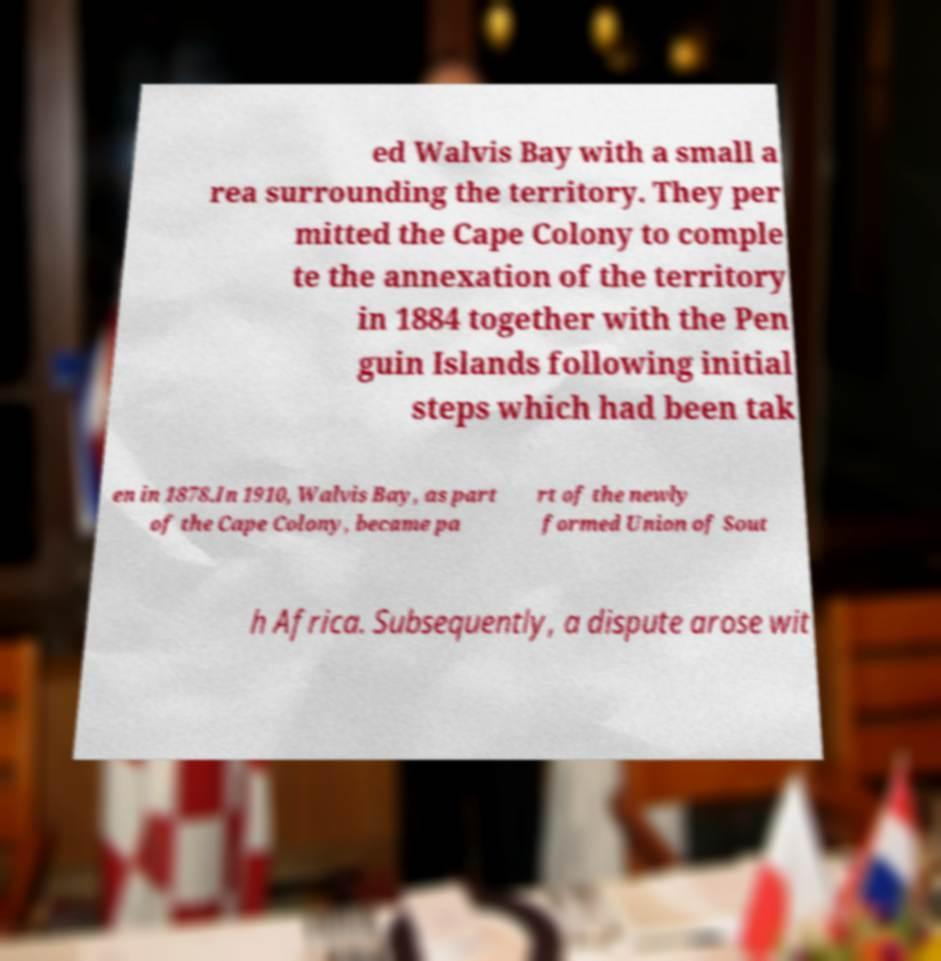Please read and relay the text visible in this image. What does it say? ed Walvis Bay with a small a rea surrounding the territory. They per mitted the Cape Colony to comple te the annexation of the territory in 1884 together with the Pen guin Islands following initial steps which had been tak en in 1878.In 1910, Walvis Bay, as part of the Cape Colony, became pa rt of the newly formed Union of Sout h Africa. Subsequently, a dispute arose wit 